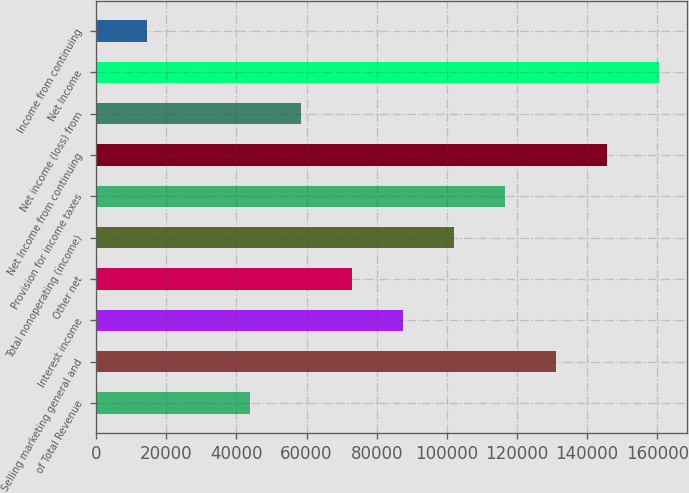Convert chart. <chart><loc_0><loc_0><loc_500><loc_500><bar_chart><fcel>of Total Revenue<fcel>Selling marketing general and<fcel>Interest income<fcel>Other net<fcel>Total nonoperating (income)<fcel>Provision for income taxes<fcel>Net Income from continuing<fcel>Net income (loss) from<fcel>Net Income<fcel>Income from continuing<nl><fcel>43746.4<fcel>131239<fcel>87492.7<fcel>72910.6<fcel>102075<fcel>116657<fcel>145821<fcel>58328.5<fcel>160403<fcel>14582.2<nl></chart> 